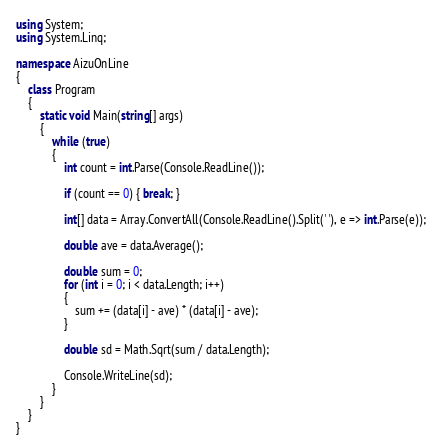<code> <loc_0><loc_0><loc_500><loc_500><_C#_>using System;
using System.Linq;

namespace AizuOnLine
{
    class Program
    {
        static void Main(string[] args)
        {
            while (true)
            {
                int count = int.Parse(Console.ReadLine());

                if (count == 0) { break; }

                int[] data = Array.ConvertAll(Console.ReadLine().Split(' '), e => int.Parse(e));

                double ave = data.Average();

                double sum = 0;
                for (int i = 0; i < data.Length; i++)
                {
                    sum += (data[i] - ave) * (data[i] - ave);
                }

                double sd = Math.Sqrt(sum / data.Length);

                Console.WriteLine(sd);
            }
        }
    }
}</code> 